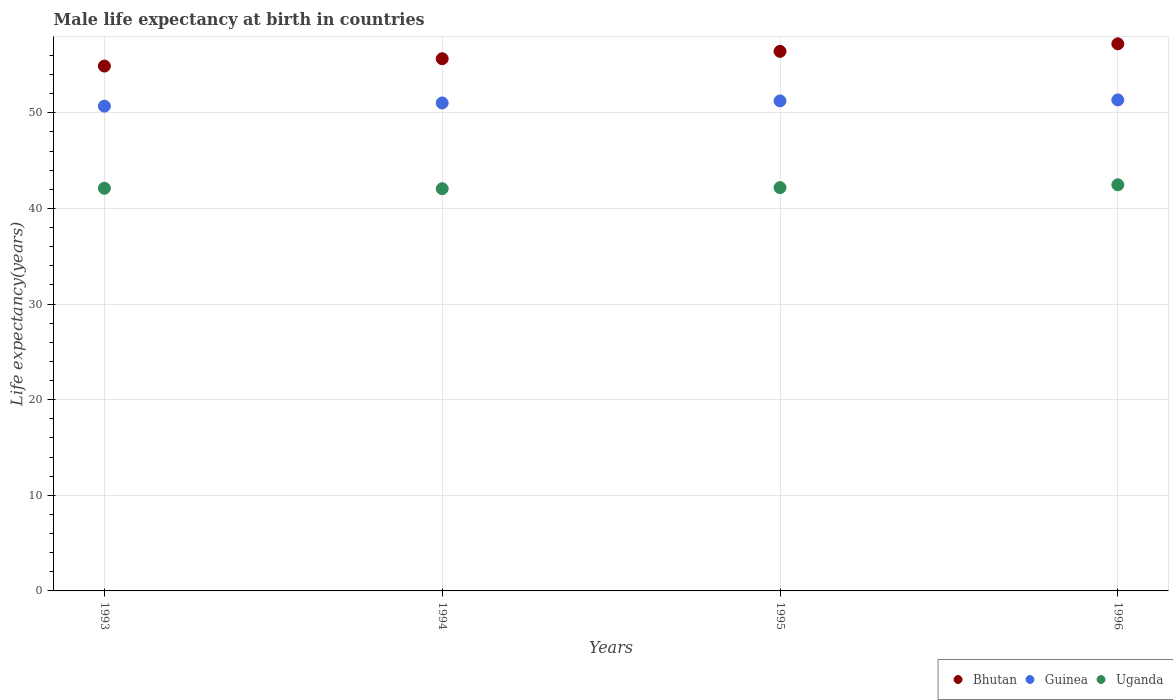Is the number of dotlines equal to the number of legend labels?
Offer a very short reply. Yes. What is the male life expectancy at birth in Bhutan in 1993?
Provide a succinct answer. 54.89. Across all years, what is the maximum male life expectancy at birth in Uganda?
Provide a short and direct response. 42.47. Across all years, what is the minimum male life expectancy at birth in Bhutan?
Your answer should be compact. 54.89. What is the total male life expectancy at birth in Guinea in the graph?
Ensure brevity in your answer.  204.33. What is the difference between the male life expectancy at birth in Guinea in 1994 and that in 1996?
Give a very brief answer. -0.32. What is the difference between the male life expectancy at birth in Guinea in 1993 and the male life expectancy at birth in Uganda in 1994?
Offer a very short reply. 8.63. What is the average male life expectancy at birth in Guinea per year?
Your response must be concise. 51.08. In the year 1993, what is the difference between the male life expectancy at birth in Guinea and male life expectancy at birth in Uganda?
Your response must be concise. 8.59. In how many years, is the male life expectancy at birth in Bhutan greater than 26 years?
Your answer should be compact. 4. What is the ratio of the male life expectancy at birth in Guinea in 1994 to that in 1995?
Your answer should be compact. 1. What is the difference between the highest and the second highest male life expectancy at birth in Uganda?
Your answer should be compact. 0.3. What is the difference between the highest and the lowest male life expectancy at birth in Guinea?
Provide a short and direct response. 0.65. In how many years, is the male life expectancy at birth in Uganda greater than the average male life expectancy at birth in Uganda taken over all years?
Ensure brevity in your answer.  1. Is the sum of the male life expectancy at birth in Uganda in 1993 and 1994 greater than the maximum male life expectancy at birth in Guinea across all years?
Your answer should be compact. Yes. Is it the case that in every year, the sum of the male life expectancy at birth in Uganda and male life expectancy at birth in Bhutan  is greater than the male life expectancy at birth in Guinea?
Ensure brevity in your answer.  Yes. Does the male life expectancy at birth in Guinea monotonically increase over the years?
Offer a very short reply. Yes. Is the male life expectancy at birth in Uganda strictly greater than the male life expectancy at birth in Bhutan over the years?
Your response must be concise. No. How many dotlines are there?
Your answer should be very brief. 3. How many years are there in the graph?
Keep it short and to the point. 4. Are the values on the major ticks of Y-axis written in scientific E-notation?
Your response must be concise. No. Does the graph contain any zero values?
Your answer should be compact. No. How many legend labels are there?
Ensure brevity in your answer.  3. What is the title of the graph?
Your answer should be compact. Male life expectancy at birth in countries. What is the label or title of the X-axis?
Provide a short and direct response. Years. What is the label or title of the Y-axis?
Your answer should be very brief. Life expectancy(years). What is the Life expectancy(years) in Bhutan in 1993?
Your response must be concise. 54.89. What is the Life expectancy(years) in Guinea in 1993?
Make the answer very short. 50.7. What is the Life expectancy(years) in Uganda in 1993?
Ensure brevity in your answer.  42.11. What is the Life expectancy(years) of Bhutan in 1994?
Keep it short and to the point. 55.66. What is the Life expectancy(years) of Guinea in 1994?
Your answer should be compact. 51.03. What is the Life expectancy(years) in Uganda in 1994?
Offer a very short reply. 42.06. What is the Life expectancy(years) in Bhutan in 1995?
Provide a short and direct response. 56.43. What is the Life expectancy(years) in Guinea in 1995?
Your answer should be very brief. 51.25. What is the Life expectancy(years) of Uganda in 1995?
Offer a terse response. 42.18. What is the Life expectancy(years) in Bhutan in 1996?
Your response must be concise. 57.22. What is the Life expectancy(years) of Guinea in 1996?
Provide a succinct answer. 51.35. What is the Life expectancy(years) of Uganda in 1996?
Provide a short and direct response. 42.47. Across all years, what is the maximum Life expectancy(years) in Bhutan?
Your answer should be compact. 57.22. Across all years, what is the maximum Life expectancy(years) in Guinea?
Offer a terse response. 51.35. Across all years, what is the maximum Life expectancy(years) of Uganda?
Keep it short and to the point. 42.47. Across all years, what is the minimum Life expectancy(years) in Bhutan?
Your answer should be compact. 54.89. Across all years, what is the minimum Life expectancy(years) in Guinea?
Give a very brief answer. 50.7. Across all years, what is the minimum Life expectancy(years) in Uganda?
Make the answer very short. 42.06. What is the total Life expectancy(years) in Bhutan in the graph?
Provide a short and direct response. 224.19. What is the total Life expectancy(years) of Guinea in the graph?
Your response must be concise. 204.32. What is the total Life expectancy(years) of Uganda in the graph?
Make the answer very short. 168.82. What is the difference between the Life expectancy(years) of Bhutan in 1993 and that in 1994?
Give a very brief answer. -0.77. What is the difference between the Life expectancy(years) in Guinea in 1993 and that in 1994?
Your response must be concise. -0.33. What is the difference between the Life expectancy(years) of Uganda in 1993 and that in 1994?
Provide a succinct answer. 0.05. What is the difference between the Life expectancy(years) of Bhutan in 1993 and that in 1995?
Ensure brevity in your answer.  -1.54. What is the difference between the Life expectancy(years) in Guinea in 1993 and that in 1995?
Ensure brevity in your answer.  -0.55. What is the difference between the Life expectancy(years) of Uganda in 1993 and that in 1995?
Ensure brevity in your answer.  -0.07. What is the difference between the Life expectancy(years) of Bhutan in 1993 and that in 1996?
Give a very brief answer. -2.33. What is the difference between the Life expectancy(years) in Guinea in 1993 and that in 1996?
Provide a short and direct response. -0.65. What is the difference between the Life expectancy(years) in Uganda in 1993 and that in 1996?
Provide a succinct answer. -0.36. What is the difference between the Life expectancy(years) of Bhutan in 1994 and that in 1995?
Keep it short and to the point. -0.77. What is the difference between the Life expectancy(years) of Guinea in 1994 and that in 1995?
Your answer should be very brief. -0.22. What is the difference between the Life expectancy(years) of Uganda in 1994 and that in 1995?
Offer a very short reply. -0.11. What is the difference between the Life expectancy(years) in Bhutan in 1994 and that in 1996?
Your answer should be compact. -1.56. What is the difference between the Life expectancy(years) in Guinea in 1994 and that in 1996?
Your answer should be compact. -0.32. What is the difference between the Life expectancy(years) in Uganda in 1994 and that in 1996?
Your answer should be compact. -0.41. What is the difference between the Life expectancy(years) in Bhutan in 1995 and that in 1996?
Provide a succinct answer. -0.79. What is the difference between the Life expectancy(years) in Guinea in 1995 and that in 1996?
Keep it short and to the point. -0.1. What is the difference between the Life expectancy(years) of Uganda in 1995 and that in 1996?
Offer a very short reply. -0.3. What is the difference between the Life expectancy(years) of Bhutan in 1993 and the Life expectancy(years) of Guinea in 1994?
Your answer should be compact. 3.86. What is the difference between the Life expectancy(years) of Bhutan in 1993 and the Life expectancy(years) of Uganda in 1994?
Give a very brief answer. 12.83. What is the difference between the Life expectancy(years) of Guinea in 1993 and the Life expectancy(years) of Uganda in 1994?
Your answer should be compact. 8.63. What is the difference between the Life expectancy(years) in Bhutan in 1993 and the Life expectancy(years) in Guinea in 1995?
Provide a succinct answer. 3.64. What is the difference between the Life expectancy(years) of Bhutan in 1993 and the Life expectancy(years) of Uganda in 1995?
Offer a terse response. 12.71. What is the difference between the Life expectancy(years) in Guinea in 1993 and the Life expectancy(years) in Uganda in 1995?
Your answer should be compact. 8.52. What is the difference between the Life expectancy(years) of Bhutan in 1993 and the Life expectancy(years) of Guinea in 1996?
Provide a short and direct response. 3.54. What is the difference between the Life expectancy(years) in Bhutan in 1993 and the Life expectancy(years) in Uganda in 1996?
Offer a very short reply. 12.42. What is the difference between the Life expectancy(years) of Guinea in 1993 and the Life expectancy(years) of Uganda in 1996?
Keep it short and to the point. 8.22. What is the difference between the Life expectancy(years) of Bhutan in 1994 and the Life expectancy(years) of Guinea in 1995?
Your answer should be compact. 4.41. What is the difference between the Life expectancy(years) in Bhutan in 1994 and the Life expectancy(years) in Uganda in 1995?
Offer a terse response. 13.48. What is the difference between the Life expectancy(years) in Guinea in 1994 and the Life expectancy(years) in Uganda in 1995?
Make the answer very short. 8.86. What is the difference between the Life expectancy(years) of Bhutan in 1994 and the Life expectancy(years) of Guinea in 1996?
Give a very brief answer. 4.31. What is the difference between the Life expectancy(years) in Bhutan in 1994 and the Life expectancy(years) in Uganda in 1996?
Offer a terse response. 13.18. What is the difference between the Life expectancy(years) in Guinea in 1994 and the Life expectancy(years) in Uganda in 1996?
Offer a terse response. 8.56. What is the difference between the Life expectancy(years) in Bhutan in 1995 and the Life expectancy(years) in Guinea in 1996?
Keep it short and to the point. 5.08. What is the difference between the Life expectancy(years) of Bhutan in 1995 and the Life expectancy(years) of Uganda in 1996?
Make the answer very short. 13.96. What is the difference between the Life expectancy(years) of Guinea in 1995 and the Life expectancy(years) of Uganda in 1996?
Ensure brevity in your answer.  8.77. What is the average Life expectancy(years) of Bhutan per year?
Your response must be concise. 56.05. What is the average Life expectancy(years) of Guinea per year?
Your answer should be compact. 51.08. What is the average Life expectancy(years) of Uganda per year?
Keep it short and to the point. 42.21. In the year 1993, what is the difference between the Life expectancy(years) of Bhutan and Life expectancy(years) of Guinea?
Make the answer very short. 4.19. In the year 1993, what is the difference between the Life expectancy(years) in Bhutan and Life expectancy(years) in Uganda?
Your answer should be compact. 12.78. In the year 1993, what is the difference between the Life expectancy(years) in Guinea and Life expectancy(years) in Uganda?
Ensure brevity in your answer.  8.59. In the year 1994, what is the difference between the Life expectancy(years) of Bhutan and Life expectancy(years) of Guinea?
Offer a terse response. 4.62. In the year 1994, what is the difference between the Life expectancy(years) in Bhutan and Life expectancy(years) in Uganda?
Provide a short and direct response. 13.59. In the year 1994, what is the difference between the Life expectancy(years) of Guinea and Life expectancy(years) of Uganda?
Offer a terse response. 8.97. In the year 1995, what is the difference between the Life expectancy(years) of Bhutan and Life expectancy(years) of Guinea?
Your answer should be compact. 5.18. In the year 1995, what is the difference between the Life expectancy(years) in Bhutan and Life expectancy(years) in Uganda?
Keep it short and to the point. 14.25. In the year 1995, what is the difference between the Life expectancy(years) in Guinea and Life expectancy(years) in Uganda?
Provide a succinct answer. 9.07. In the year 1996, what is the difference between the Life expectancy(years) in Bhutan and Life expectancy(years) in Guinea?
Keep it short and to the point. 5.87. In the year 1996, what is the difference between the Life expectancy(years) of Bhutan and Life expectancy(years) of Uganda?
Give a very brief answer. 14.74. In the year 1996, what is the difference between the Life expectancy(years) in Guinea and Life expectancy(years) in Uganda?
Your response must be concise. 8.88. What is the ratio of the Life expectancy(years) in Bhutan in 1993 to that in 1994?
Provide a short and direct response. 0.99. What is the ratio of the Life expectancy(years) of Guinea in 1993 to that in 1994?
Give a very brief answer. 0.99. What is the ratio of the Life expectancy(years) of Bhutan in 1993 to that in 1995?
Your response must be concise. 0.97. What is the ratio of the Life expectancy(years) of Guinea in 1993 to that in 1995?
Make the answer very short. 0.99. What is the ratio of the Life expectancy(years) in Bhutan in 1993 to that in 1996?
Offer a terse response. 0.96. What is the ratio of the Life expectancy(years) in Guinea in 1993 to that in 1996?
Provide a succinct answer. 0.99. What is the ratio of the Life expectancy(years) of Bhutan in 1994 to that in 1995?
Keep it short and to the point. 0.99. What is the ratio of the Life expectancy(years) of Bhutan in 1994 to that in 1996?
Provide a succinct answer. 0.97. What is the ratio of the Life expectancy(years) in Uganda in 1994 to that in 1996?
Your answer should be very brief. 0.99. What is the ratio of the Life expectancy(years) of Bhutan in 1995 to that in 1996?
Ensure brevity in your answer.  0.99. What is the difference between the highest and the second highest Life expectancy(years) in Bhutan?
Provide a short and direct response. 0.79. What is the difference between the highest and the second highest Life expectancy(years) in Guinea?
Offer a terse response. 0.1. What is the difference between the highest and the second highest Life expectancy(years) in Uganda?
Provide a short and direct response. 0.3. What is the difference between the highest and the lowest Life expectancy(years) in Bhutan?
Keep it short and to the point. 2.33. What is the difference between the highest and the lowest Life expectancy(years) in Guinea?
Your answer should be very brief. 0.65. What is the difference between the highest and the lowest Life expectancy(years) of Uganda?
Keep it short and to the point. 0.41. 